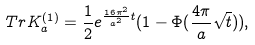Convert formula to latex. <formula><loc_0><loc_0><loc_500><loc_500>T r K _ { a } ^ { ( 1 ) } = \frac { 1 } { 2 } e ^ { \frac { 1 6 \pi ^ { 2 } } { a ^ { 2 } } t } ( 1 - \Phi ( \frac { 4 \pi } { a } \sqrt { t } ) ) ,</formula> 